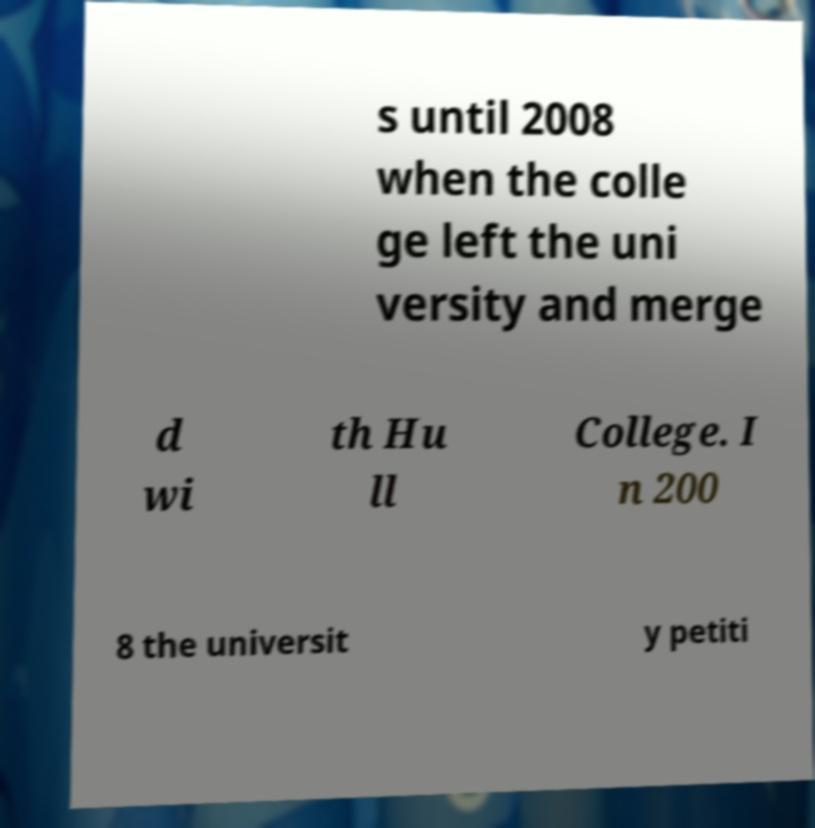I need the written content from this picture converted into text. Can you do that? s until 2008 when the colle ge left the uni versity and merge d wi th Hu ll College. I n 200 8 the universit y petiti 